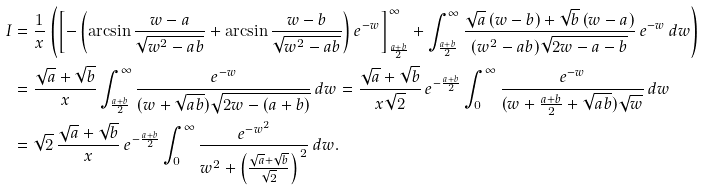<formula> <loc_0><loc_0><loc_500><loc_500>I & = \frac { 1 } { x } \left ( \left [ - \left ( \arcsin \frac { w - a } { \sqrt { w ^ { 2 } - a b } } + \arcsin \frac { w - b } { \sqrt { w ^ { 2 } - a b } } \right ) e ^ { - w } \right ] _ { \frac { a + b } { 2 } } ^ { \infty } + \int _ { \frac { a + b } { 2 } } ^ { \infty } \frac { \sqrt { a } \, ( w - b ) + \sqrt { b } \, ( w - a ) } { ( w ^ { 2 } - a b ) \sqrt { 2 w - a - b } } \, e ^ { - w } \, d w \right ) \\ & = \frac { \sqrt { a } + \sqrt { b } } { x } \int _ { \frac { a + b } { 2 } } ^ { \infty } \frac { e ^ { - w } } { ( w + \sqrt { a b } ) \sqrt { 2 w - ( a + b ) } } \, d w = \frac { \sqrt { a } + \sqrt { b } } { x \sqrt { 2 } } \, e ^ { - \frac { a + b } { 2 } } \int _ { 0 } ^ { \infty } \frac { e ^ { - w } } { ( w + \frac { a + b } { 2 } + \sqrt { a b } ) \sqrt { w } } \, d w \\ & = \sqrt { 2 } \, \frac { \sqrt { a } + \sqrt { b } } { x } \, e ^ { - \frac { a + b } { 2 } } \int _ { 0 } ^ { \infty } \frac { e ^ { - w ^ { 2 } } } { w ^ { 2 } + \left ( \frac { \sqrt { a } + \sqrt { b } } { \sqrt { 2 } } \right ) ^ { \, 2 } } \, d w .</formula> 